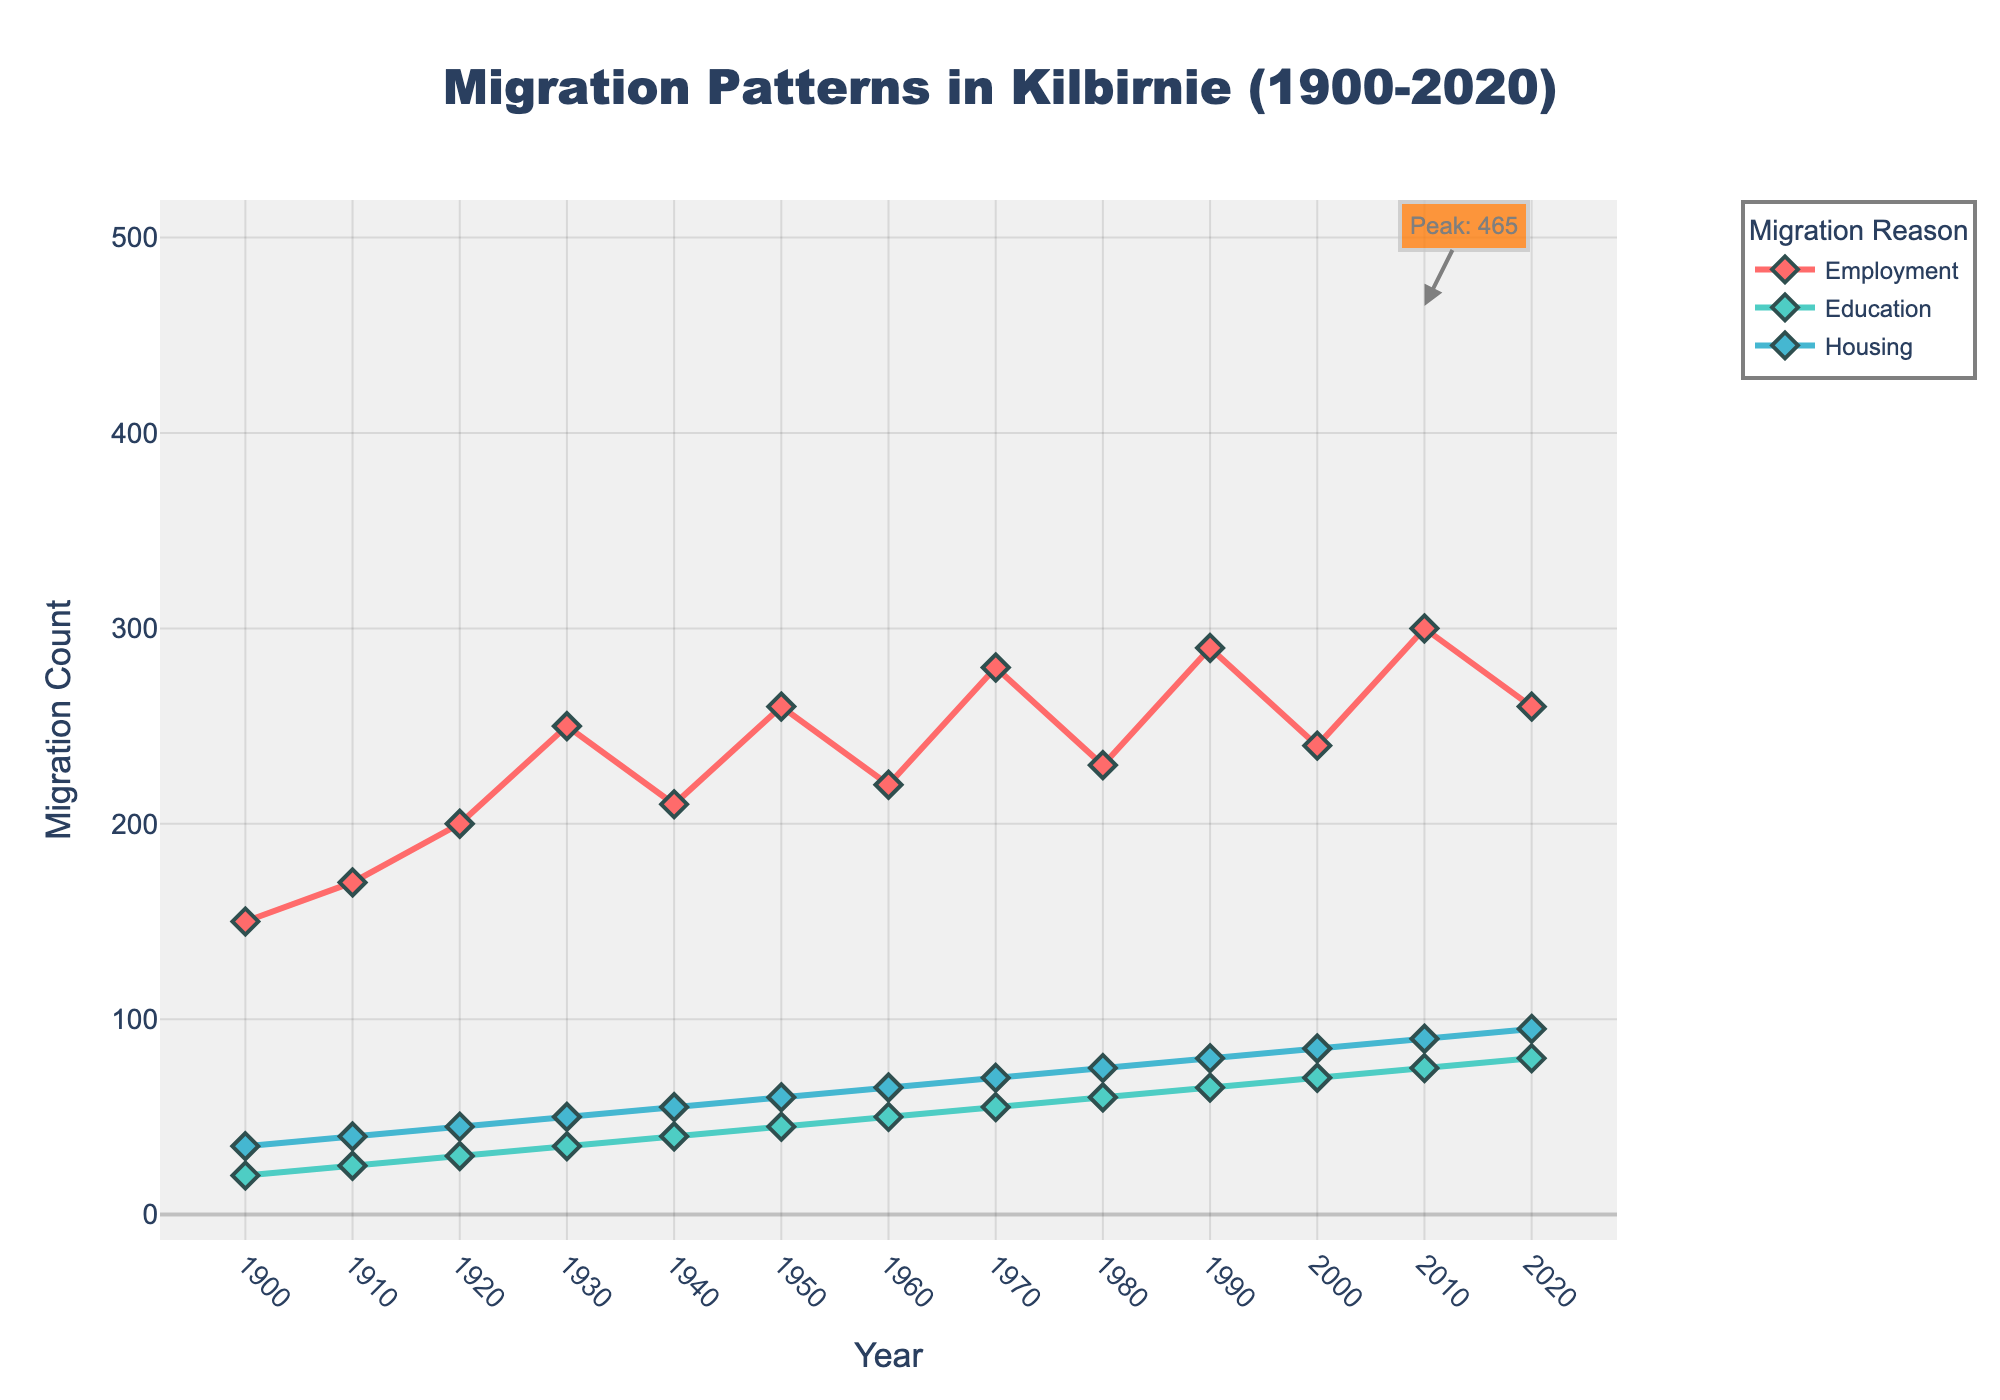What is the title of the figure? The title of the figure is usually displayed at the top of the plot. Here, it is clear that the title is "Migration Patterns in Kilbirnie (1900-2020)" as mentioned in the 'update_layout' section of the code.
Answer: Migration Patterns in Kilbirnie (1900-2020) What are the y-axis and x-axis titles? The x-axis title is typically along the bottom and the y-axis title is along the side. According to the code, the x-axis title is "Year" and the y-axis title is "Migration Count".
Answer: Year, Migration Count How many categories of migration reasons are displayed and what are they? The plot uses different colors or markers to represent different migration reasons. According to the 'categories' data and plot traces, there are three categories: Employment, Education, and Housing.
Answer: Three; Employment, Education, Housing Which category has the highest migration count in 2020? To find this, look at the last data point for each category on the plot. According to the data, Employment has a count of 260, Education has 80, and Housing has 95 in 2020. Therefore, Employment has the highest count.
Answer: Employment In which year did the total migration count peak, and what was that count? The highest migration count is annotated on the plot. According to the code, the peak occurred in 2010 with a total count. Summing up the 2010 counts: Employment (300) + Education (75) + Housing (90) gives 465. This matches the annotation logic in the code.
Answer: 2010, 465 How did the migration count for employment change from 1900 to 2020? This requires comparing the first and last data points for the Employment category. According to the data, it starts at 150 in 1900 and ends at 260 in 2020, which indicates an increase of 110.
Answer: Increased by 110 What is the trend of migration due to education from 1900 to 2020? Observing the data points for education over the years: 20 in 1900 to 80 in 2020. This indicates a general upward trend.
Answer: Upward trend Which year showed the highest migration count for housing? Look at the data points for Housing category over the years. According to the data, 2020 had the highest count of 95.
Answer: 2020 Compare the migration counts for education in 1950 and 2000. Which year had a higher count and by how much? In 1950, the count for Education was 45, and in 2000, it was 70. The difference can be calculated as 70 - 45 = 25; therefore, 2000 had a higher count by 25.
Answer: 2000 by 25 What was the total migration count in 1970? Summing up the counts from each category in 1970: Employment (280), Education (55), Housing (70). The total is 280 + 55 + 70 = 405.
Answer: 405 